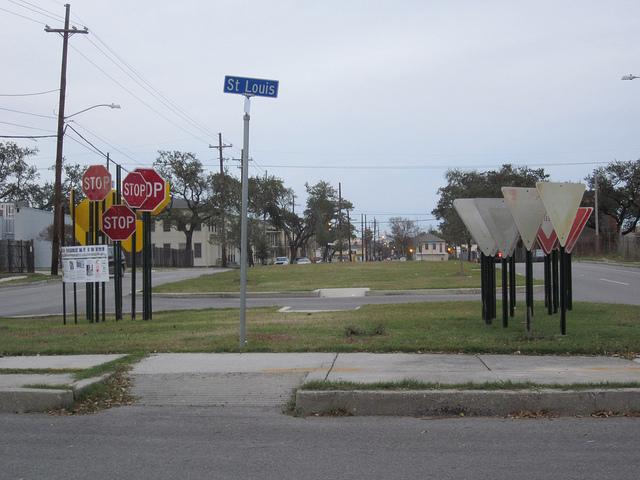Is this one building?
Concise answer only. No. Is it a sunny day?
Give a very brief answer. No. What color is the edge of the sidewalk?
Short answer required. Gray. What color is the photo?
Write a very short answer. Green, white, blue. What is written on the blue sign?
Be succinct. St louis. How many stop signs?
Short answer required. 4. What kind of trees are in the background?
Give a very brief answer. Oak. What does the sign say?
Concise answer only. Stop. What type of buildings are in the background?
Write a very short answer. Houses. What Parkway is this?
Write a very short answer. St louis. What is the name of the street?
Concise answer only. St louis. Are the police involved?
Concise answer only. No. How many signs are point right?
Concise answer only. 10. Is there a lady walking on the sidewalk?
Be succinct. No. Is there a stop sign on the street?
Keep it brief. Yes. How many orange barrels do you see?
Be succinct. 0. Do you see numbers on the sign?
Quick response, please. No. Are there bikes here?
Concise answer only. No. Is the sky clear?
Answer briefly. Yes. What does the blue sign say?
Answer briefly. St louis. How many rickshaws are there?
Keep it brief. 0. What is the ramp for?
Quick response, please. For wheelchairs. Does someone really want people to stop here?
Be succinct. Yes. What state is this?
Concise answer only. Missouri. Is the stop sign tall?
Quick response, please. Yes. 